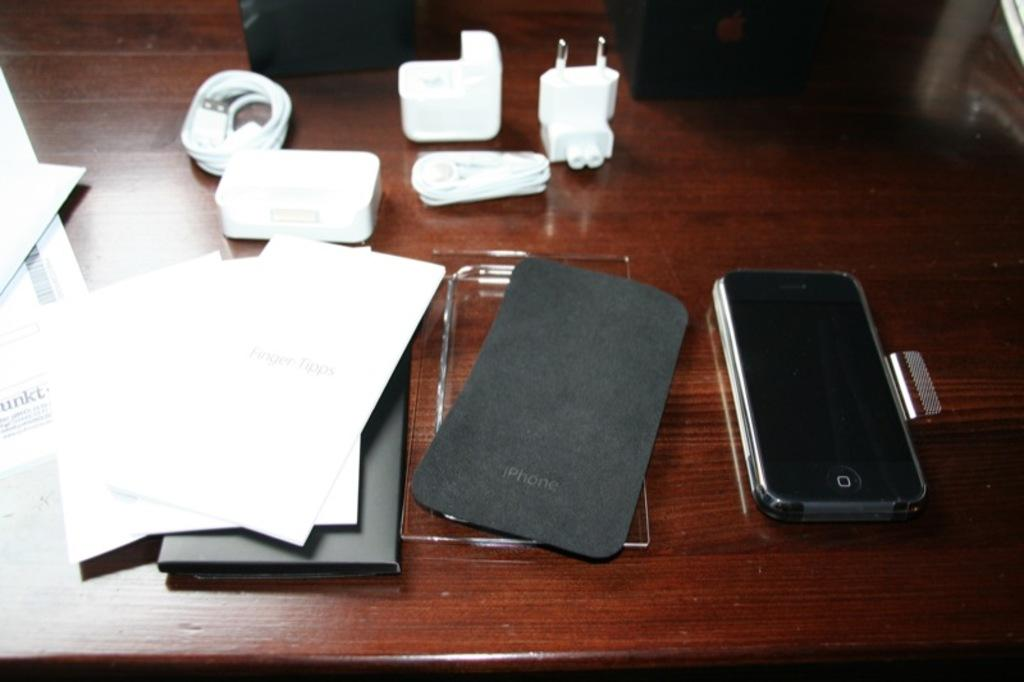<image>
Give a short and clear explanation of the subsequent image. An apple branded iphone next to its protective case and accessories. 